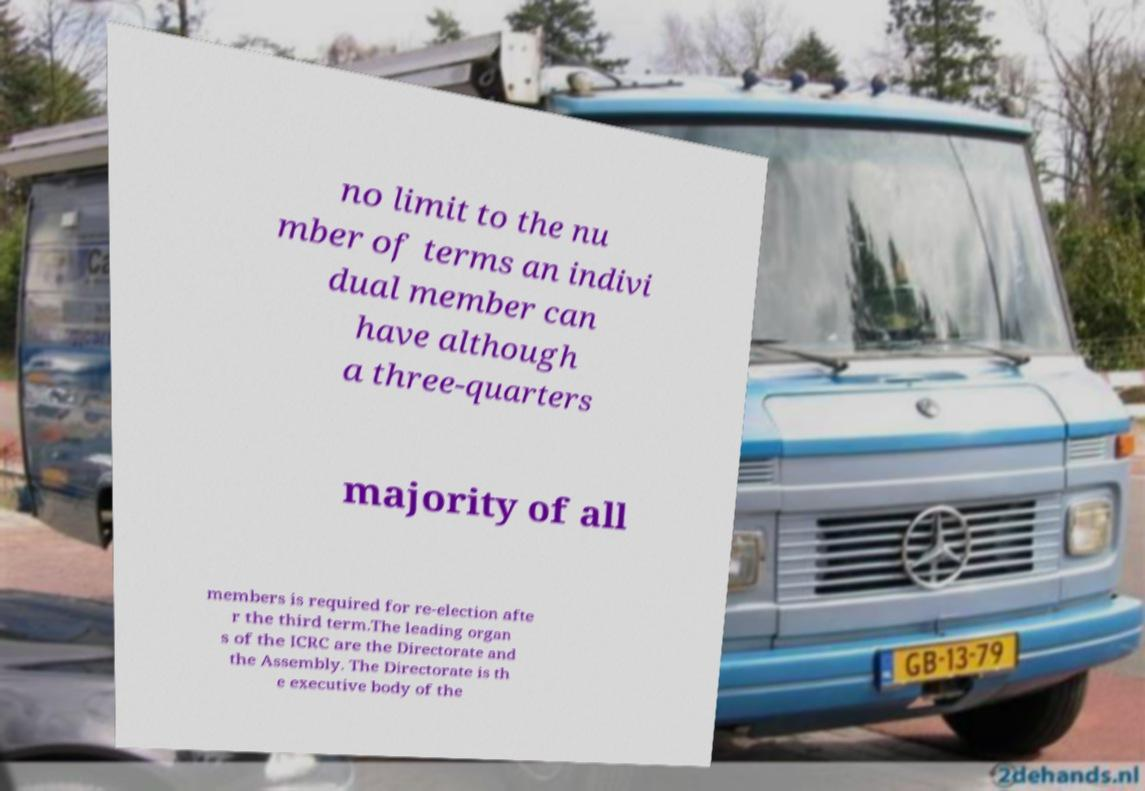Could you extract and type out the text from this image? no limit to the nu mber of terms an indivi dual member can have although a three-quarters majority of all members is required for re-election afte r the third term.The leading organ s of the ICRC are the Directorate and the Assembly. The Directorate is th e executive body of the 